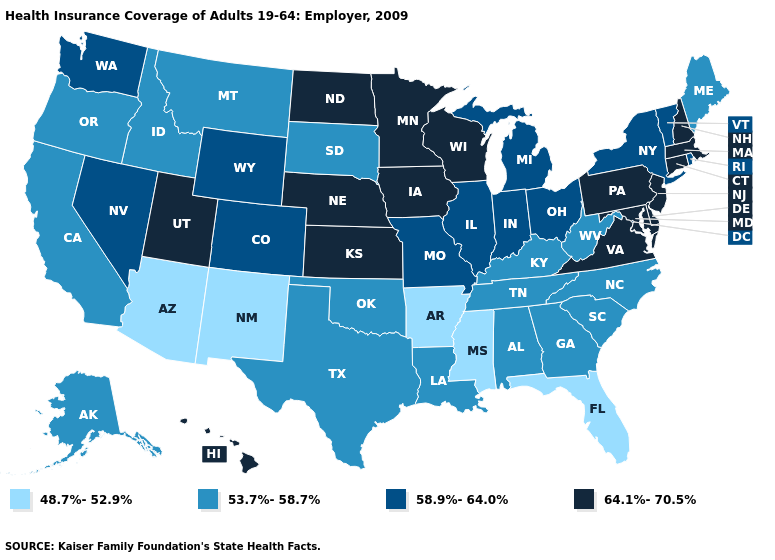Among the states that border West Virginia , which have the lowest value?
Keep it brief. Kentucky. Which states have the highest value in the USA?
Give a very brief answer. Connecticut, Delaware, Hawaii, Iowa, Kansas, Maryland, Massachusetts, Minnesota, Nebraska, New Hampshire, New Jersey, North Dakota, Pennsylvania, Utah, Virginia, Wisconsin. Does New Hampshire have the highest value in the USA?
Short answer required. Yes. Name the states that have a value in the range 53.7%-58.7%?
Short answer required. Alabama, Alaska, California, Georgia, Idaho, Kentucky, Louisiana, Maine, Montana, North Carolina, Oklahoma, Oregon, South Carolina, South Dakota, Tennessee, Texas, West Virginia. Does Maine have the highest value in the Northeast?
Quick response, please. No. What is the lowest value in states that border Georgia?
Answer briefly. 48.7%-52.9%. Which states hav the highest value in the MidWest?
Answer briefly. Iowa, Kansas, Minnesota, Nebraska, North Dakota, Wisconsin. What is the value of Minnesota?
Concise answer only. 64.1%-70.5%. Name the states that have a value in the range 53.7%-58.7%?
Give a very brief answer. Alabama, Alaska, California, Georgia, Idaho, Kentucky, Louisiana, Maine, Montana, North Carolina, Oklahoma, Oregon, South Carolina, South Dakota, Tennessee, Texas, West Virginia. What is the highest value in the USA?
Be succinct. 64.1%-70.5%. Name the states that have a value in the range 53.7%-58.7%?
Be succinct. Alabama, Alaska, California, Georgia, Idaho, Kentucky, Louisiana, Maine, Montana, North Carolina, Oklahoma, Oregon, South Carolina, South Dakota, Tennessee, Texas, West Virginia. Name the states that have a value in the range 53.7%-58.7%?
Quick response, please. Alabama, Alaska, California, Georgia, Idaho, Kentucky, Louisiana, Maine, Montana, North Carolina, Oklahoma, Oregon, South Carolina, South Dakota, Tennessee, Texas, West Virginia. Name the states that have a value in the range 48.7%-52.9%?
Give a very brief answer. Arizona, Arkansas, Florida, Mississippi, New Mexico. Among the states that border Michigan , which have the highest value?
Answer briefly. Wisconsin. Which states have the highest value in the USA?
Give a very brief answer. Connecticut, Delaware, Hawaii, Iowa, Kansas, Maryland, Massachusetts, Minnesota, Nebraska, New Hampshire, New Jersey, North Dakota, Pennsylvania, Utah, Virginia, Wisconsin. 